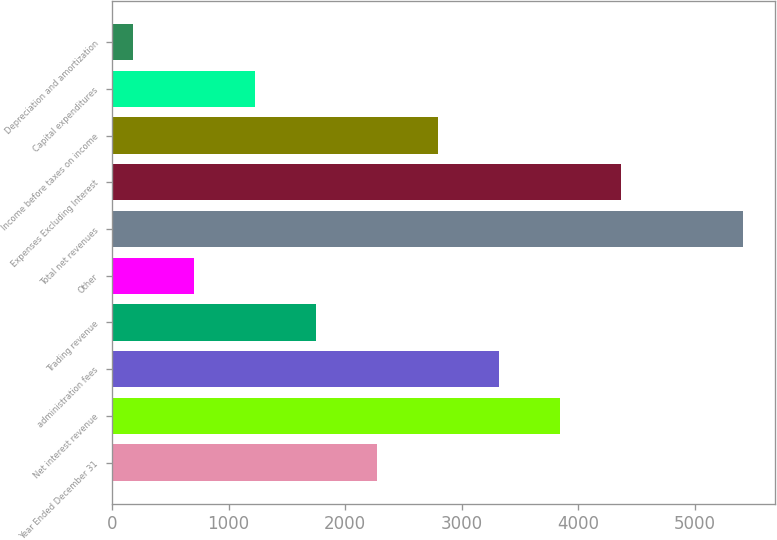Convert chart to OTSL. <chart><loc_0><loc_0><loc_500><loc_500><bar_chart><fcel>Year Ended December 31<fcel>Net interest revenue<fcel>administration fees<fcel>Trading revenue<fcel>Other<fcel>Total net revenues<fcel>Expenses Excluding Interest<fcel>Income before taxes on income<fcel>Capital expenditures<fcel>Depreciation and amortization<nl><fcel>2272.4<fcel>3841.7<fcel>3318.6<fcel>1749.3<fcel>703.1<fcel>5411<fcel>4364.8<fcel>2795.5<fcel>1226.2<fcel>180<nl></chart> 